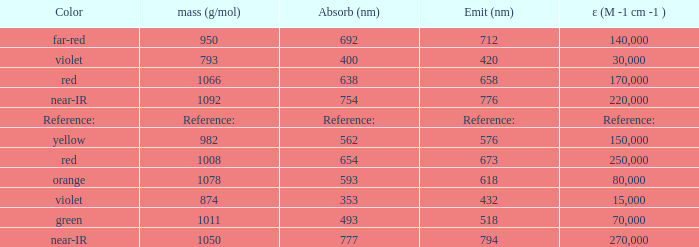Which ε (M -1 cm -1) has a molar mass of 1008 g/mol? 250000.0. 